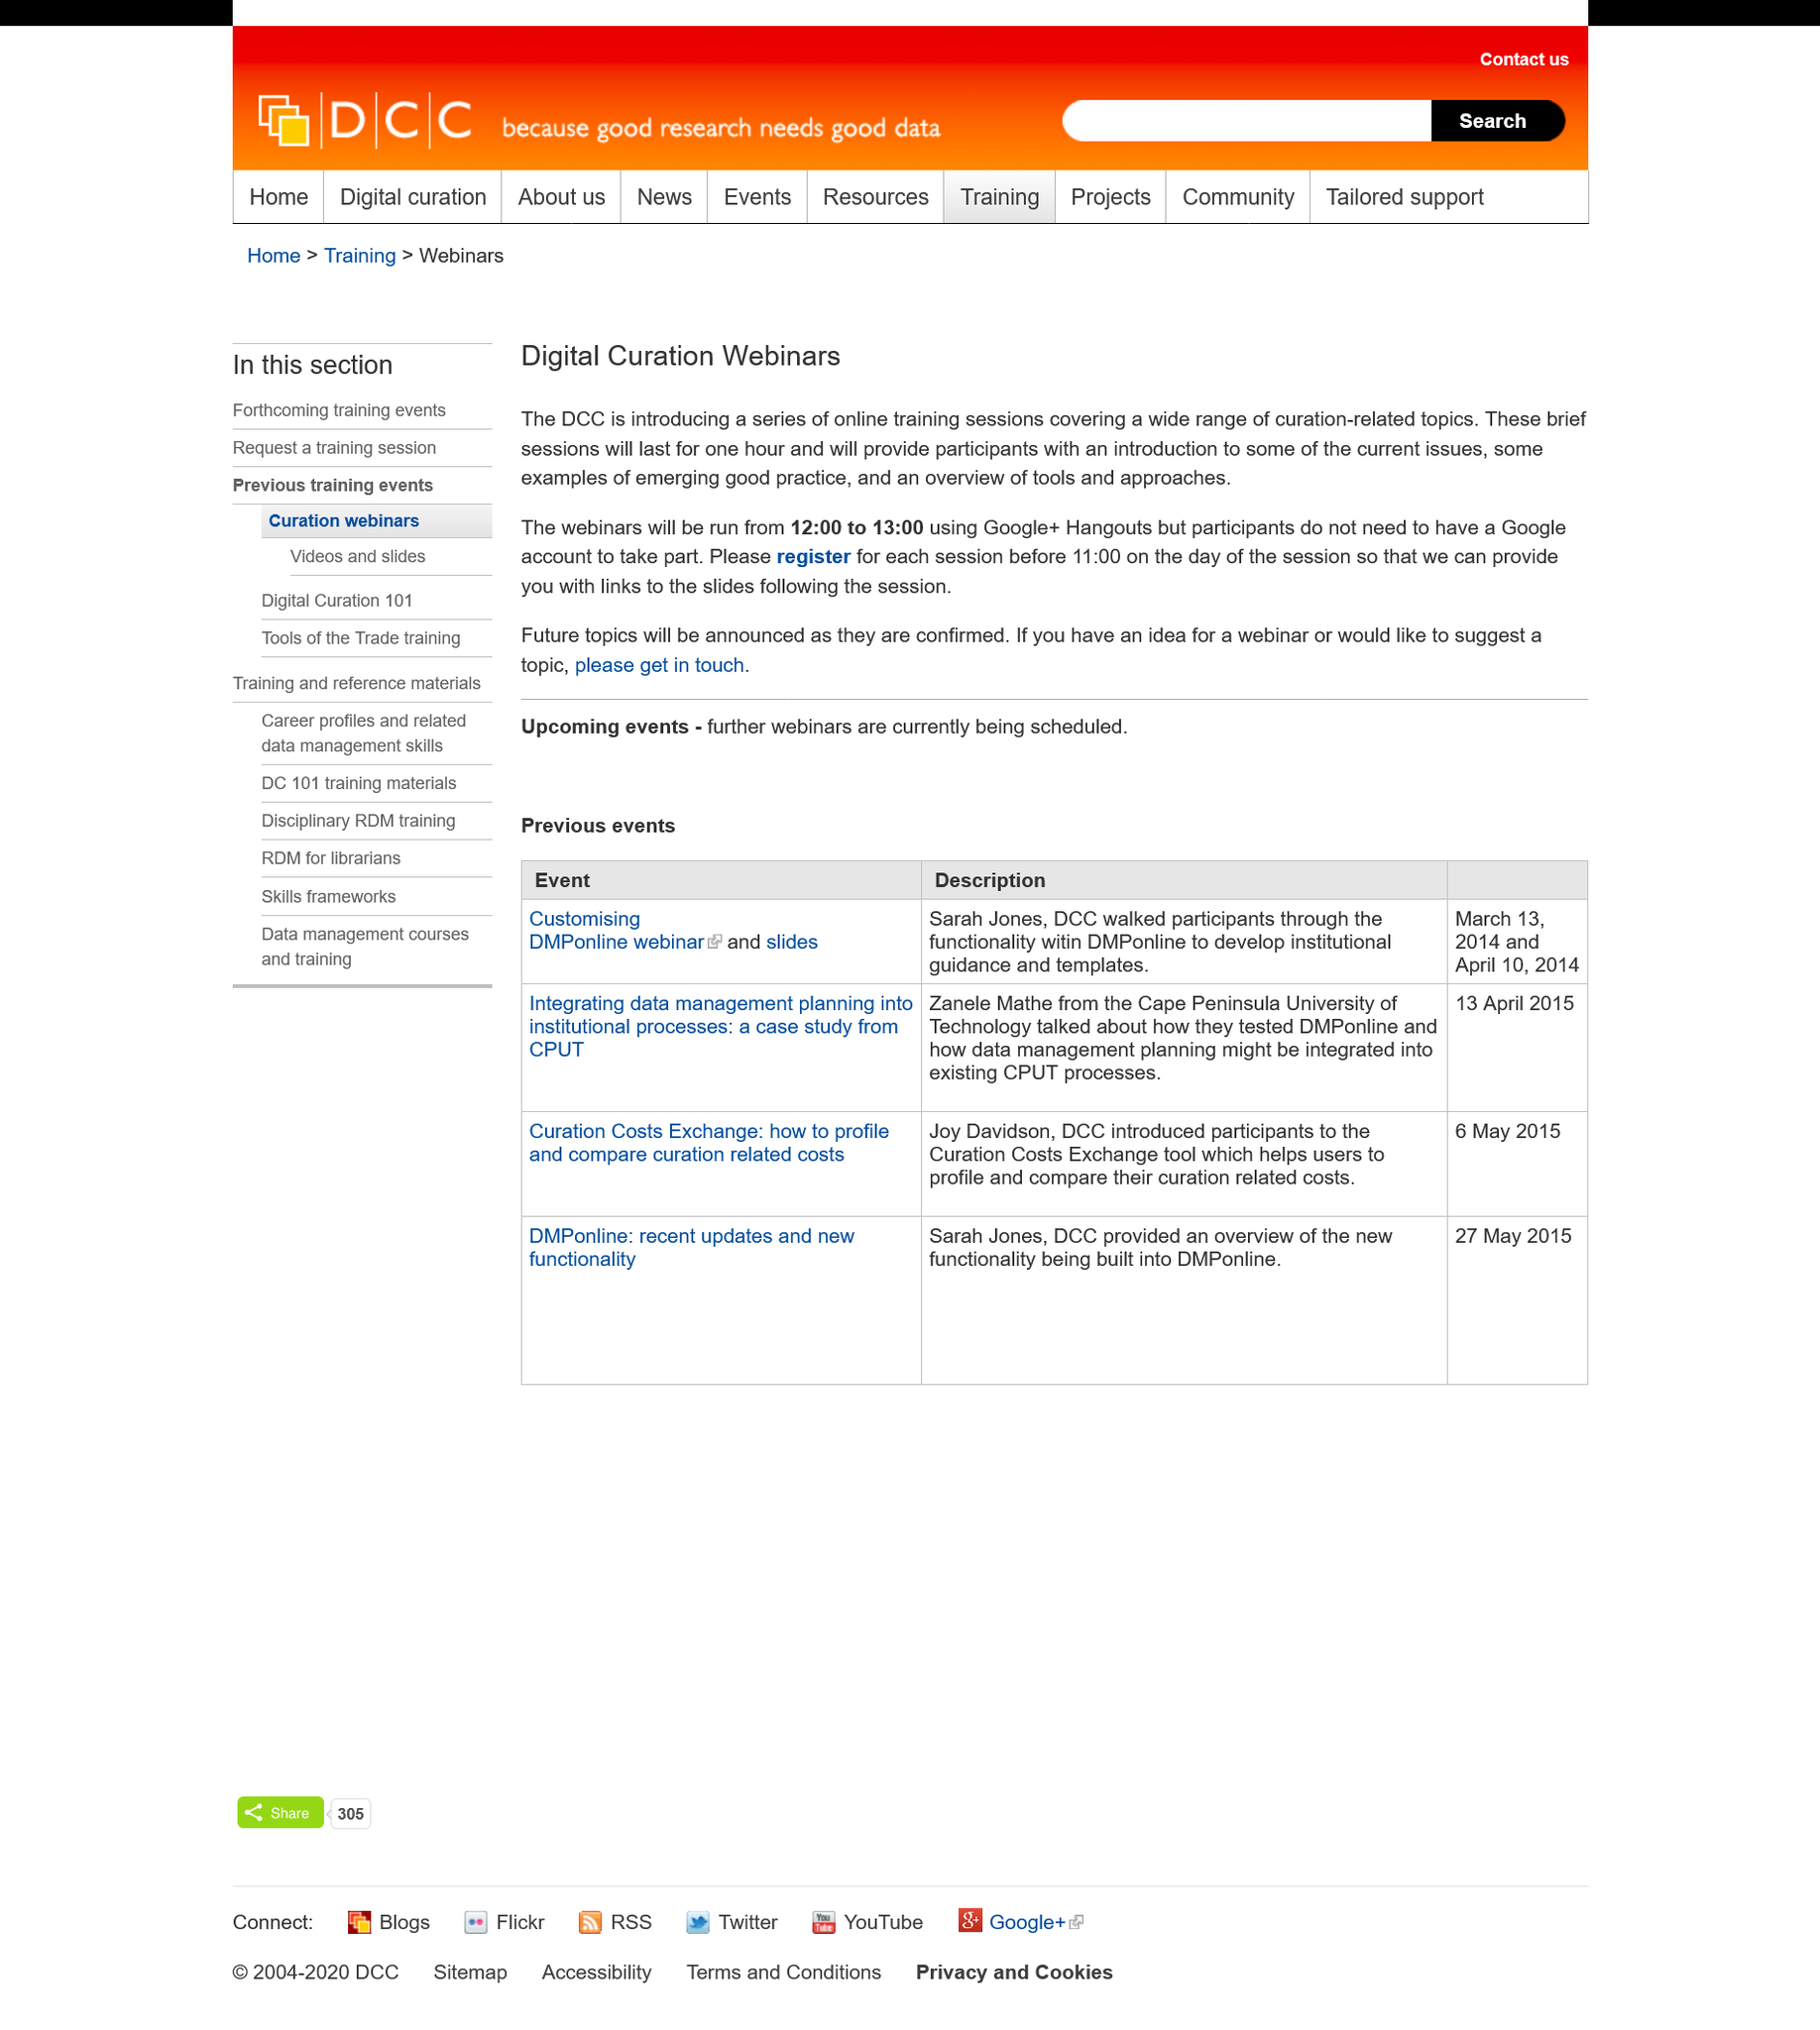Specify some key components in this picture. The duration of DCC webinars is one hour. The DCC webinars can be accessed through Google+ Hangouts. The DCC webinars will run from 12:00 pm to 1:00 pm. 